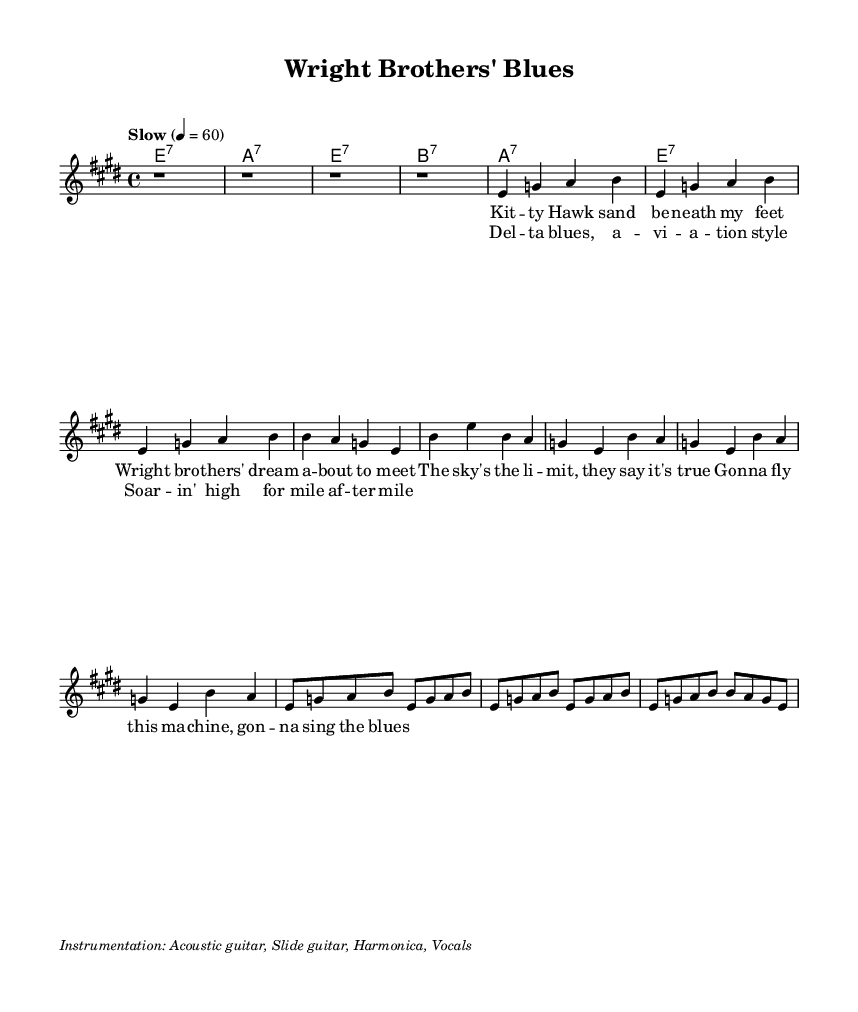What is the key signature of this music? The key signature is E major, which has four sharps: F sharp, C sharp, G sharp, and D sharp. This is indicated at the beginning of the music sheet where the sharps are noted.
Answer: E major What is the time signature of this music? The time signature shown at the beginning is 4/4, also known as common time, meaning there are four beats in a measure and the quarter note gets one beat.
Answer: 4/4 What is the tempo marking for this music? The tempo is marked as "Slow" with a metronome marking of 60 beats per minute, indicating a relaxed pace for the performance. This is found in the tempo indication line.
Answer: Slow 4 = 60 How many measures are in the verse? The verse consists of four measures, which can be counted by examining the structure of the melody and lyrics that appear together, where each section is outlined in the score clearly.
Answer: 4 What instruments are indicated for this piece? The instrumentation mentioned in the markup includes Acoustic guitar, Slide guitar, Harmonica, and Vocals. This information can be found in the notation at the bottom of the score where instrument names are specified.
Answer: Acoustic guitar, Slide guitar, Harmonica, Vocals How does the chorus differ from the verse musically? The chorus features a repetitive melodic pattern with a focus on a more straightforward and memorable phrase structure, contrasting with the more varied melody of the verse. This can be determined by comparing the musical notation of the two sections.
Answer: Repetitive melodic pattern What musical genre does this piece belong to? This piece is classified as Blues, specifically inspired by Delta blues, which is evident from the lyrical content reflecting themes of aviation pioneers, as well as the musical characteristics typical of the genre. This can be inferred from the title and the style indicated.
Answer: Blues 